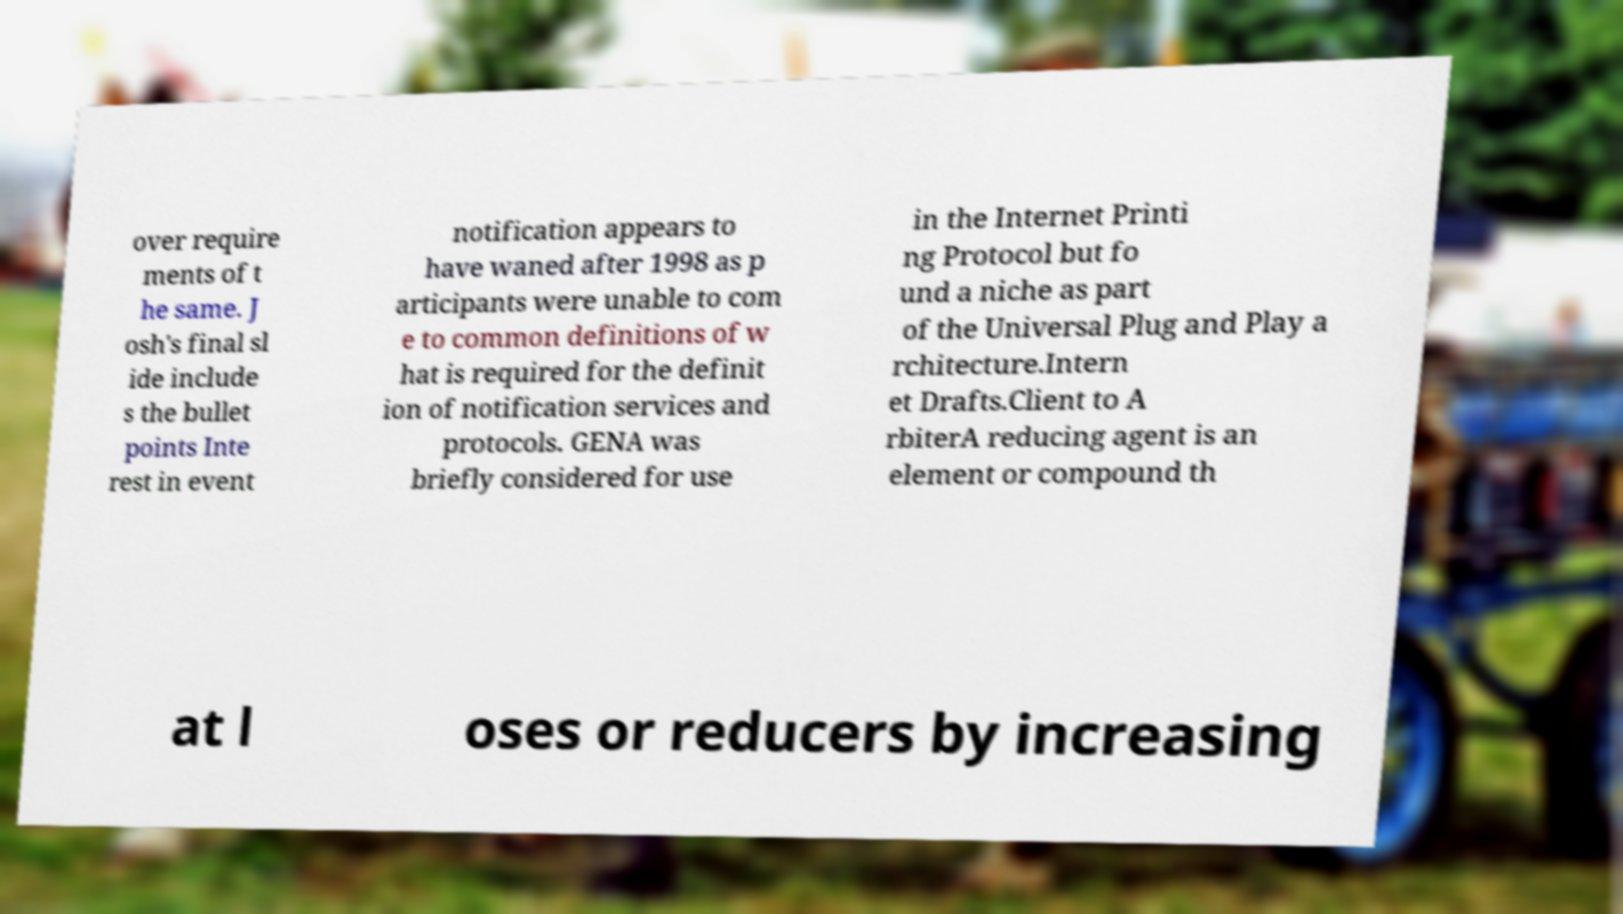Please read and relay the text visible in this image. What does it say? over require ments of t he same. J osh's final sl ide include s the bullet points Inte rest in event notification appears to have waned after 1998 as p articipants were unable to com e to common definitions of w hat is required for the definit ion of notification services and protocols. GENA was briefly considered for use in the Internet Printi ng Protocol but fo und a niche as part of the Universal Plug and Play a rchitecture.Intern et Drafts.Client to A rbiterA reducing agent is an element or compound th at l oses or reducers by increasing 